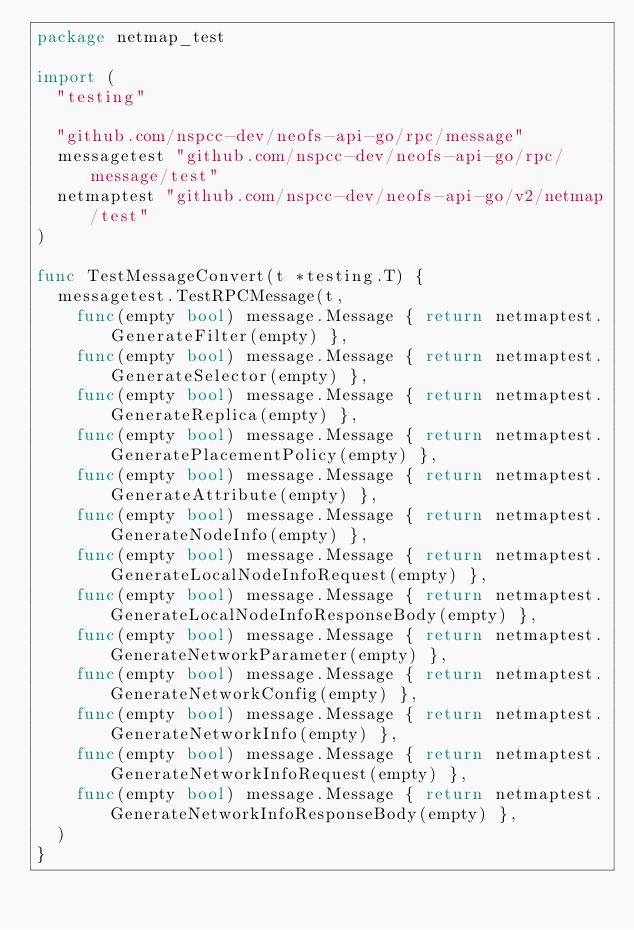Convert code to text. <code><loc_0><loc_0><loc_500><loc_500><_Go_>package netmap_test

import (
	"testing"

	"github.com/nspcc-dev/neofs-api-go/rpc/message"
	messagetest "github.com/nspcc-dev/neofs-api-go/rpc/message/test"
	netmaptest "github.com/nspcc-dev/neofs-api-go/v2/netmap/test"
)

func TestMessageConvert(t *testing.T) {
	messagetest.TestRPCMessage(t,
		func(empty bool) message.Message { return netmaptest.GenerateFilter(empty) },
		func(empty bool) message.Message { return netmaptest.GenerateSelector(empty) },
		func(empty bool) message.Message { return netmaptest.GenerateReplica(empty) },
		func(empty bool) message.Message { return netmaptest.GeneratePlacementPolicy(empty) },
		func(empty bool) message.Message { return netmaptest.GenerateAttribute(empty) },
		func(empty bool) message.Message { return netmaptest.GenerateNodeInfo(empty) },
		func(empty bool) message.Message { return netmaptest.GenerateLocalNodeInfoRequest(empty) },
		func(empty bool) message.Message { return netmaptest.GenerateLocalNodeInfoResponseBody(empty) },
		func(empty bool) message.Message { return netmaptest.GenerateNetworkParameter(empty) },
		func(empty bool) message.Message { return netmaptest.GenerateNetworkConfig(empty) },
		func(empty bool) message.Message { return netmaptest.GenerateNetworkInfo(empty) },
		func(empty bool) message.Message { return netmaptest.GenerateNetworkInfoRequest(empty) },
		func(empty bool) message.Message { return netmaptest.GenerateNetworkInfoResponseBody(empty) },
	)
}
</code> 